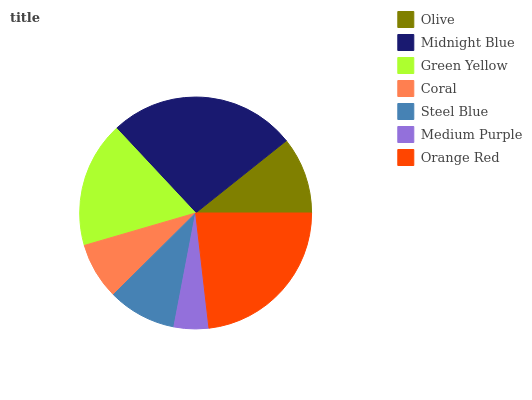Is Medium Purple the minimum?
Answer yes or no. Yes. Is Midnight Blue the maximum?
Answer yes or no. Yes. Is Green Yellow the minimum?
Answer yes or no. No. Is Green Yellow the maximum?
Answer yes or no. No. Is Midnight Blue greater than Green Yellow?
Answer yes or no. Yes. Is Green Yellow less than Midnight Blue?
Answer yes or no. Yes. Is Green Yellow greater than Midnight Blue?
Answer yes or no. No. Is Midnight Blue less than Green Yellow?
Answer yes or no. No. Is Olive the high median?
Answer yes or no. Yes. Is Olive the low median?
Answer yes or no. Yes. Is Medium Purple the high median?
Answer yes or no. No. Is Orange Red the low median?
Answer yes or no. No. 